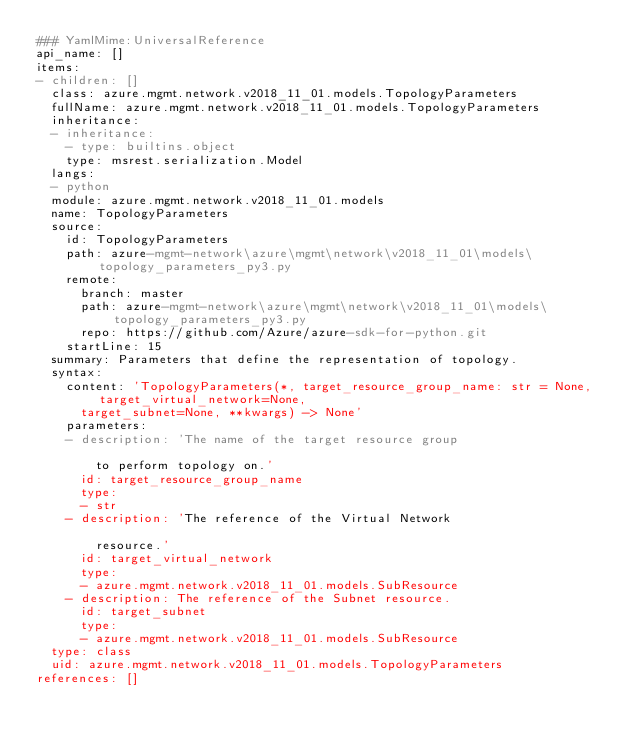<code> <loc_0><loc_0><loc_500><loc_500><_YAML_>### YamlMime:UniversalReference
api_name: []
items:
- children: []
  class: azure.mgmt.network.v2018_11_01.models.TopologyParameters
  fullName: azure.mgmt.network.v2018_11_01.models.TopologyParameters
  inheritance:
  - inheritance:
    - type: builtins.object
    type: msrest.serialization.Model
  langs:
  - python
  module: azure.mgmt.network.v2018_11_01.models
  name: TopologyParameters
  source:
    id: TopologyParameters
    path: azure-mgmt-network\azure\mgmt\network\v2018_11_01\models\topology_parameters_py3.py
    remote:
      branch: master
      path: azure-mgmt-network\azure\mgmt\network\v2018_11_01\models\topology_parameters_py3.py
      repo: https://github.com/Azure/azure-sdk-for-python.git
    startLine: 15
  summary: Parameters that define the representation of topology.
  syntax:
    content: 'TopologyParameters(*, target_resource_group_name: str = None, target_virtual_network=None,
      target_subnet=None, **kwargs) -> None'
    parameters:
    - description: 'The name of the target resource group

        to perform topology on.'
      id: target_resource_group_name
      type:
      - str
    - description: 'The reference of the Virtual Network

        resource.'
      id: target_virtual_network
      type:
      - azure.mgmt.network.v2018_11_01.models.SubResource
    - description: The reference of the Subnet resource.
      id: target_subnet
      type:
      - azure.mgmt.network.v2018_11_01.models.SubResource
  type: class
  uid: azure.mgmt.network.v2018_11_01.models.TopologyParameters
references: []
</code> 